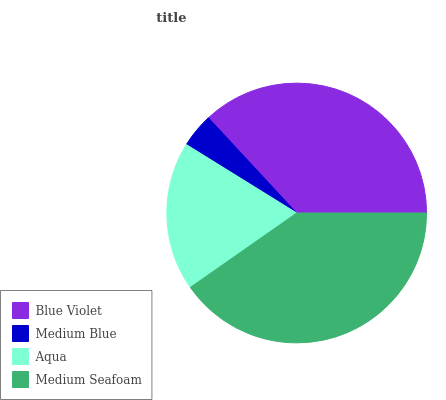Is Medium Blue the minimum?
Answer yes or no. Yes. Is Medium Seafoam the maximum?
Answer yes or no. Yes. Is Aqua the minimum?
Answer yes or no. No. Is Aqua the maximum?
Answer yes or no. No. Is Aqua greater than Medium Blue?
Answer yes or no. Yes. Is Medium Blue less than Aqua?
Answer yes or no. Yes. Is Medium Blue greater than Aqua?
Answer yes or no. No. Is Aqua less than Medium Blue?
Answer yes or no. No. Is Blue Violet the high median?
Answer yes or no. Yes. Is Aqua the low median?
Answer yes or no. Yes. Is Medium Seafoam the high median?
Answer yes or no. No. Is Medium Blue the low median?
Answer yes or no. No. 